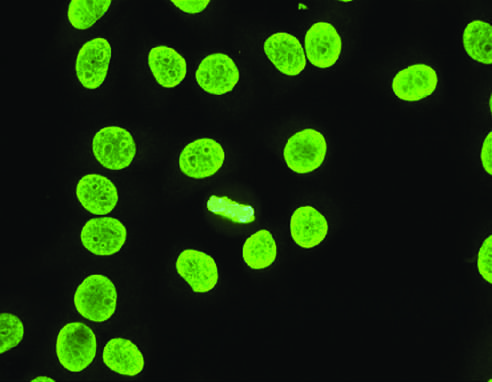how is homogeneous or diffuse staining of nuclei?
Answer the question using a single word or phrase. Common 